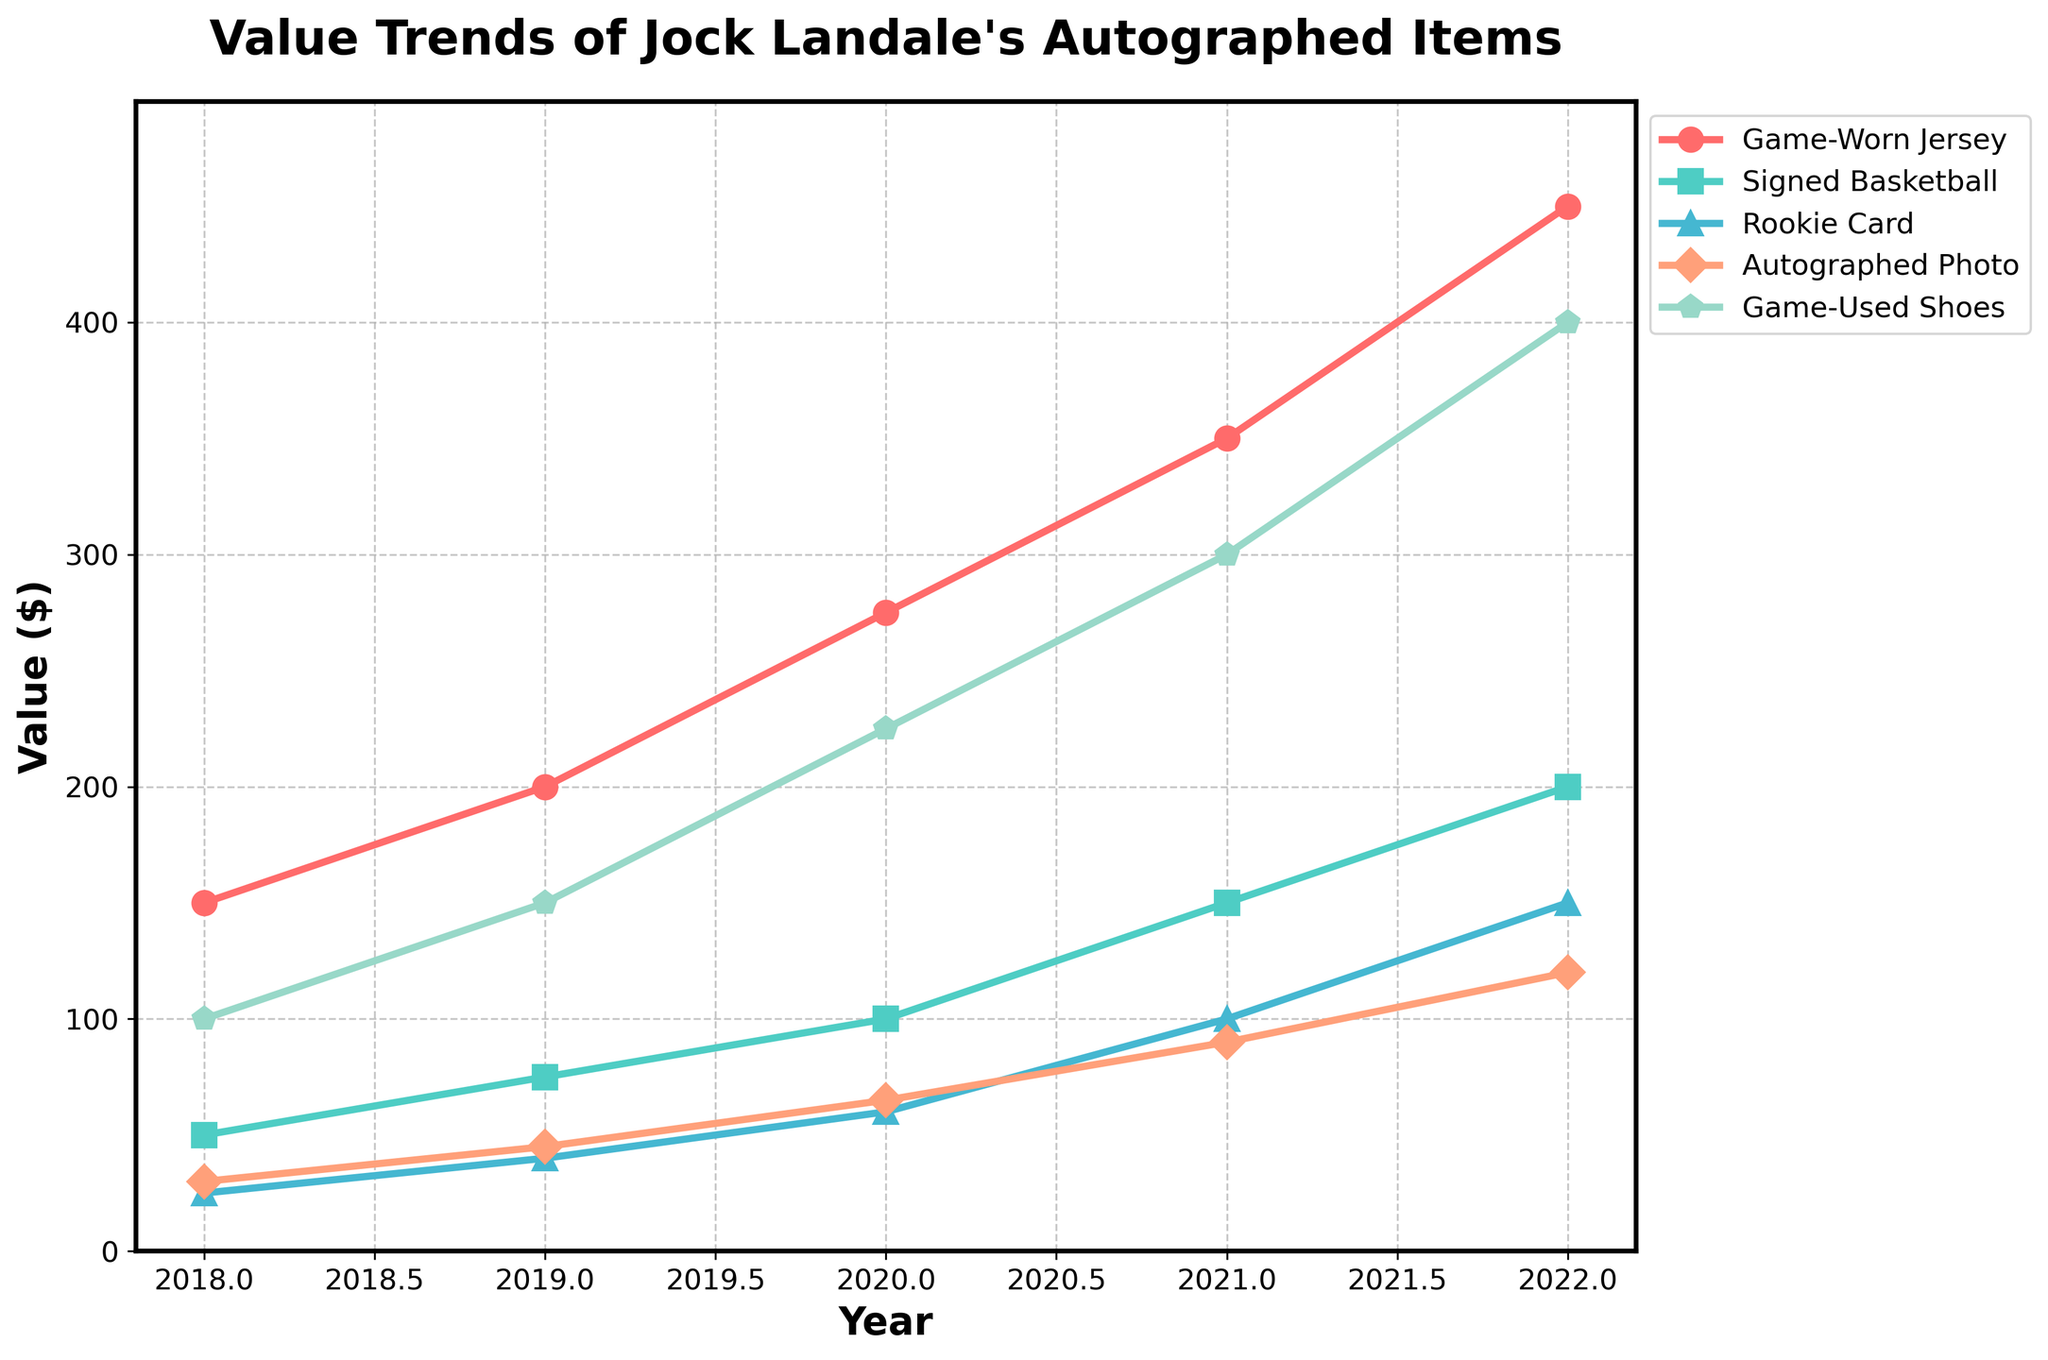What's the highest value reached by the autographed items in the past 5 years? Looking at the figure, the highest value reached is for Game-Worn Jerseys in 2022, where it peaked at $450.
Answer: $450 Which autographed item has shown the greatest increase in value from 2018 to 2022? To determine this, we must compare the value increase of each item from 2018 to 2022. Game-Worn Jersey increased from $150 to $450 (difference of $300), Signed Basketball from $50 to $200 (difference of $150), Rookie Card from $25 to $150 (difference of $125), Autographed Photo from $30 to $120 (difference of $90), and Game-Used Shoes from $100 to $400 (difference of $300). Both Game-Worn Jerseys and Game-Used Shoes have the greatest increase with $300.
Answer: Game-Worn Jerseys and Game-Used Shoes How much more valuable was a Game-Worn Jersey compared to a Signed Basketball in 2020? In 2020, the Game-Worn Jersey was valued at $275 while the Signed Basketball was valued at $100. The difference is $275 - $100 = $175.
Answer: $175 What is the average value of a Rookie Card over the 5 years? Adding the values of the Rookie Card over the 5 years: $25 (2018) + $40 (2019) + $60 (2020) + $100 (2021) + $150 (2022) = $375. Dividing by 5 years gives an average of $375 / 5 = $75.
Answer: $75 Between which consecutive years did the value of Game-Used Shoes increase the most? Checking the value increase between consecutive years: from 2018 to 2019 ($150-$100 = $50), 2019 to 2020 ($225-$150 = $75), 2020 to 2021 ($300-$225 = $75), and 2021 to 2022 ($400-$300 = $100). The largest increase happened between 2021 and 2022 by $100.
Answer: 2021 to 2022 What trend is observed for the Autographed Photo values from 2018 to 2022? Observing the line for Autographed Photos, it consistently increases each year starting from $30 in 2018 up to $120 in 2022.
Answer: Consistent increase Which item has the steepest growth rate visually? By comparing the slopes of the lines representing each item, the Game-Worn Jersey and Game-Used Shoes lines appear to have the steepest slopes, indicating the highest growth rate visually.
Answer: Game-Worn Jersey and Game-Used Shoes What is the sum of the 2020 values of all autographed items? Adding each item's value in 2020: Game-Worn Jersey ($275), Signed Basketball ($100), Rookie Card ($60), Autographed Photo ($65), and Game-Used Shoes ($225). The sum is $275 + $100 + $60 + $65 + $225 = $725.
Answer: $725 How did the value of the Game-Worn Jersey change from 2018 to 2019? In 2018, the Game-Worn Jersey was valued at $150; in 2019, it increased to $200. The change is $200 - $150 = $50.
Answer: $50 